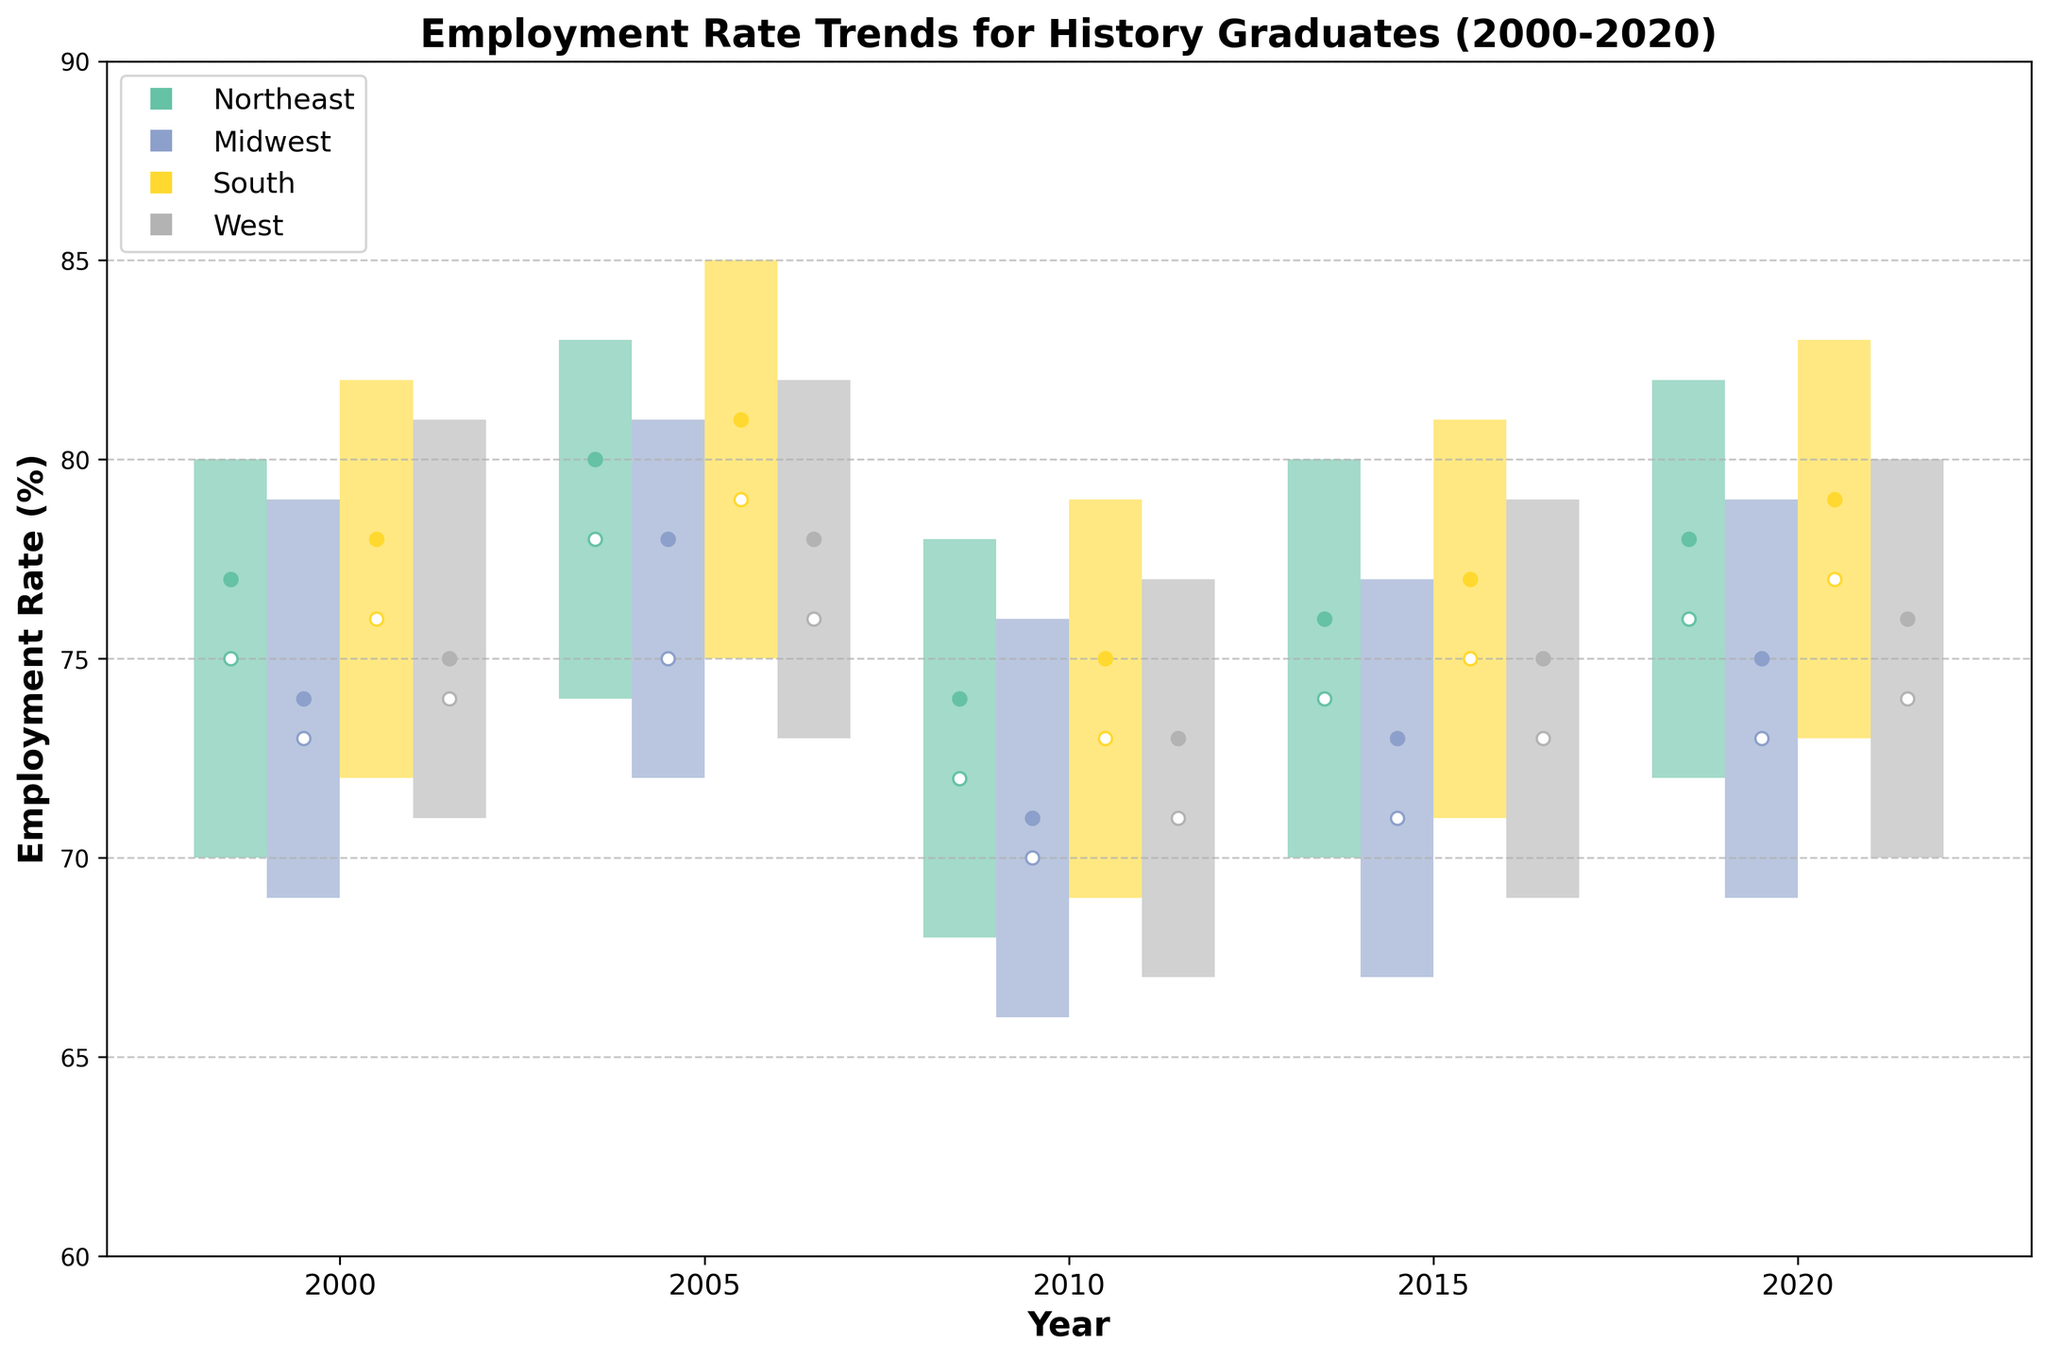How many regions are represented in the plot? The plot includes employement rate data for four regions: Northeast, Midwest, South, and West.
Answer: 4 What is the title of the plot? The title of the plot is clearly written at the top and states "Employment Rate Trends for History Graduates (2000-2020)"
Answer: Employment Rate Trends for History Graduates (2000-2020) Which region had the highest employment rate in 2005? The candlestick for each region shows that the South had the highest closing value in 2005, ending at 81%.
Answer: South Did the Northeast region see an increase or decrease in the employment rate from 2010 to 2020? By comparing the closing values for the Northeast in 2010 (74%) and 2020 (78%), it's clear that the employment rate increased.
Answer: Increase In which year did the South region have the highest high value, and what was it? By examining the high values in the candlesticks for the South region, it reached its highest in 2005 with a high value of 85%.
Answer: 2005, 85% What is the average low value for the Midwest region from 2000 to 2020? The low values for the Midwest from 2000 to 2020 are 69, 72, 66, 67, and 69. Summing these gives 343. Dividing by the 5 years gives an average: 343/5 = 68.6.
Answer: 68.6 Which two regions had the same closing employment rate in 2015, and what was it? By looking at the closing values for 2015, the Northeast and West both had a closing employment rate of 76%.
Answer: Northeast and West, 76% Was there any year when all regions had their low values below 70%? In 2010, all regions (Northeast 68%, Midwest 66%, South 69%, and West 67%) had low values below 70%.
Answer: 2010 Compare the opening employment rates in 2020 between the Northeast and the Midwest. Which is higher? The plot shows an opening value of 76% for the Northeast and 73% for the Midwest in 2020. The Northeast has the higher opening rate.
Answer: Northeast Which region had the widest range between its high and low values in any year, and how much was that range? The plot indicates that in 2005, the South region had a high of 85% and a low of 75%, giving it the widest range of 10%.
Answer: South, 10% 